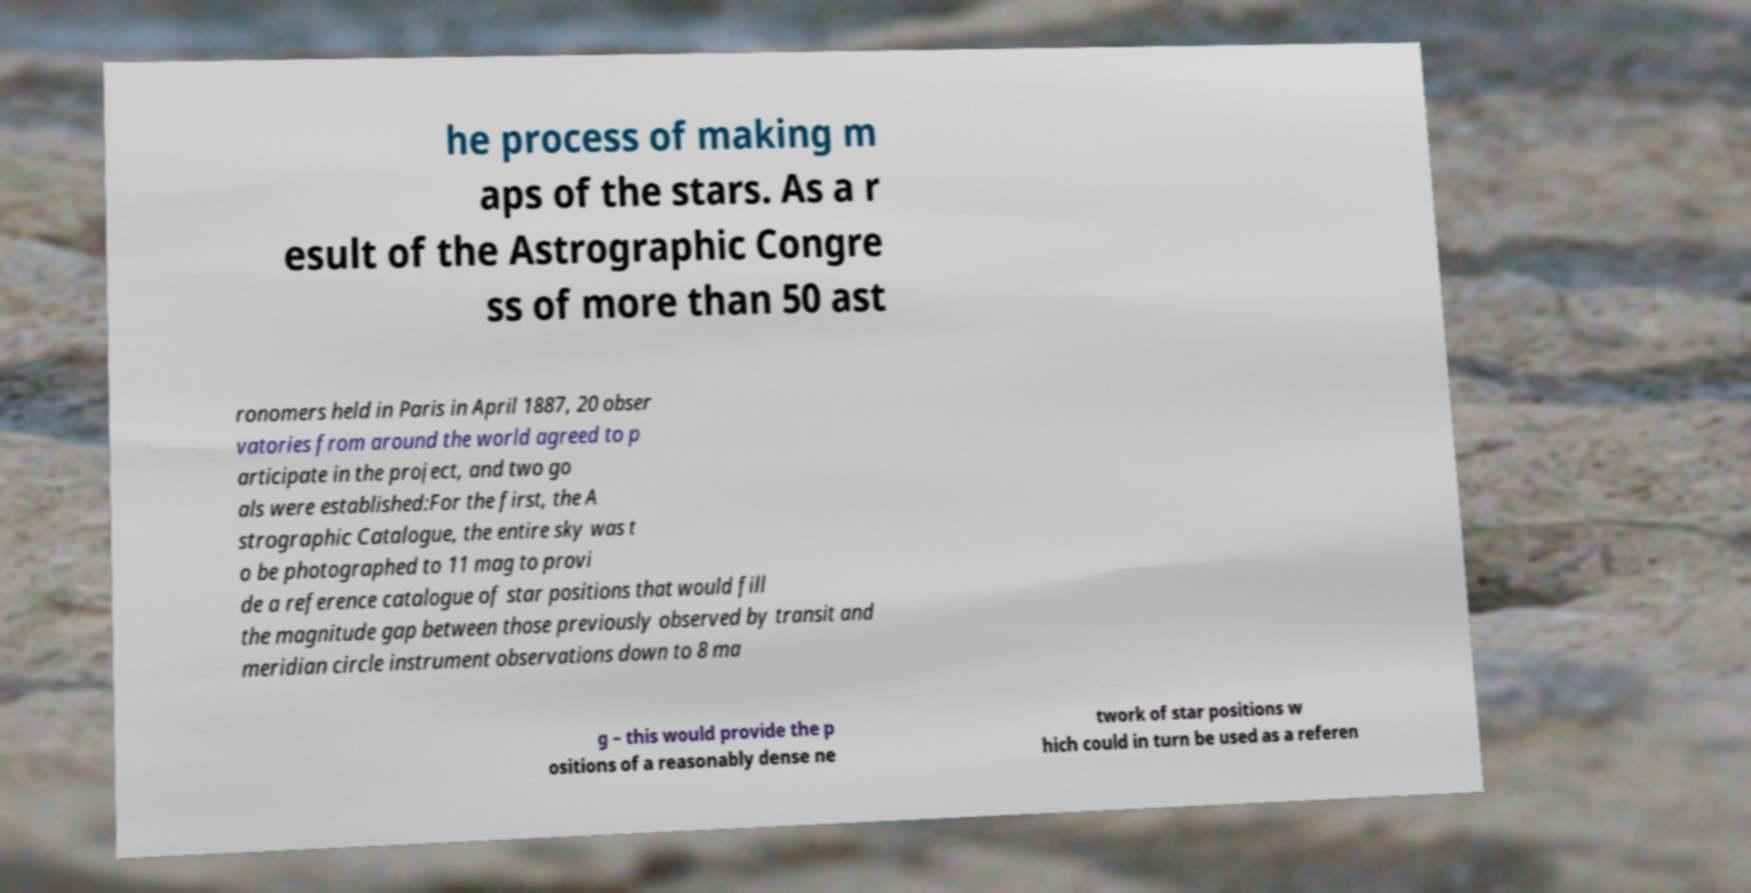I need the written content from this picture converted into text. Can you do that? he process of making m aps of the stars. As a r esult of the Astrographic Congre ss of more than 50 ast ronomers held in Paris in April 1887, 20 obser vatories from around the world agreed to p articipate in the project, and two go als were established:For the first, the A strographic Catalogue, the entire sky was t o be photographed to 11 mag to provi de a reference catalogue of star positions that would fill the magnitude gap between those previously observed by transit and meridian circle instrument observations down to 8 ma g – this would provide the p ositions of a reasonably dense ne twork of star positions w hich could in turn be used as a referen 